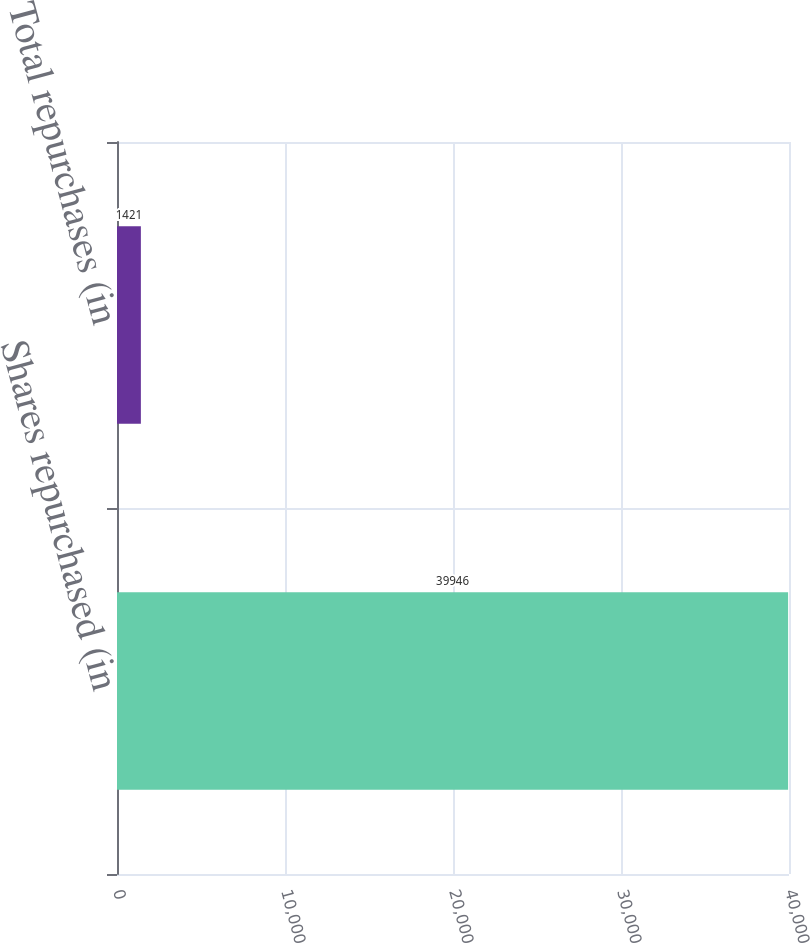Convert chart. <chart><loc_0><loc_0><loc_500><loc_500><bar_chart><fcel>Shares repurchased (in<fcel>Total repurchases (in<nl><fcel>39946<fcel>1421<nl></chart> 